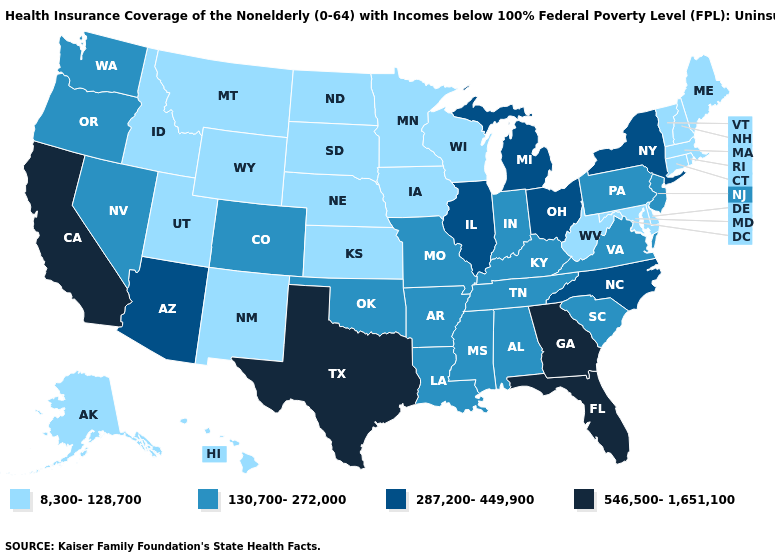Does Michigan have a higher value than North Dakota?
Answer briefly. Yes. Which states have the lowest value in the MidWest?
Write a very short answer. Iowa, Kansas, Minnesota, Nebraska, North Dakota, South Dakota, Wisconsin. Does Oregon have a higher value than Arizona?
Quick response, please. No. Which states have the lowest value in the MidWest?
Write a very short answer. Iowa, Kansas, Minnesota, Nebraska, North Dakota, South Dakota, Wisconsin. Does North Carolina have a higher value than Arizona?
Keep it brief. No. What is the value of Michigan?
Keep it brief. 287,200-449,900. What is the lowest value in states that border Tennessee?
Answer briefly. 130,700-272,000. What is the highest value in the USA?
Give a very brief answer. 546,500-1,651,100. Which states have the highest value in the USA?
Short answer required. California, Florida, Georgia, Texas. What is the highest value in the South ?
Write a very short answer. 546,500-1,651,100. What is the highest value in the South ?
Give a very brief answer. 546,500-1,651,100. Name the states that have a value in the range 546,500-1,651,100?
Answer briefly. California, Florida, Georgia, Texas. Does the map have missing data?
Short answer required. No. Name the states that have a value in the range 546,500-1,651,100?
Give a very brief answer. California, Florida, Georgia, Texas. What is the highest value in states that border Delaware?
Concise answer only. 130,700-272,000. 